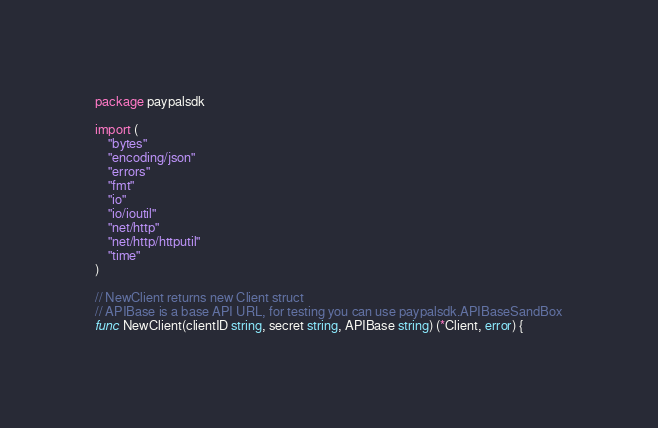<code> <loc_0><loc_0><loc_500><loc_500><_Go_>package paypalsdk

import (
	"bytes"
	"encoding/json"
	"errors"
	"fmt"
	"io"
	"io/ioutil"
	"net/http"
	"net/http/httputil"
	"time"
)

// NewClient returns new Client struct
// APIBase is a base API URL, for testing you can use paypalsdk.APIBaseSandBox
func NewClient(clientID string, secret string, APIBase string) (*Client, error) {</code> 